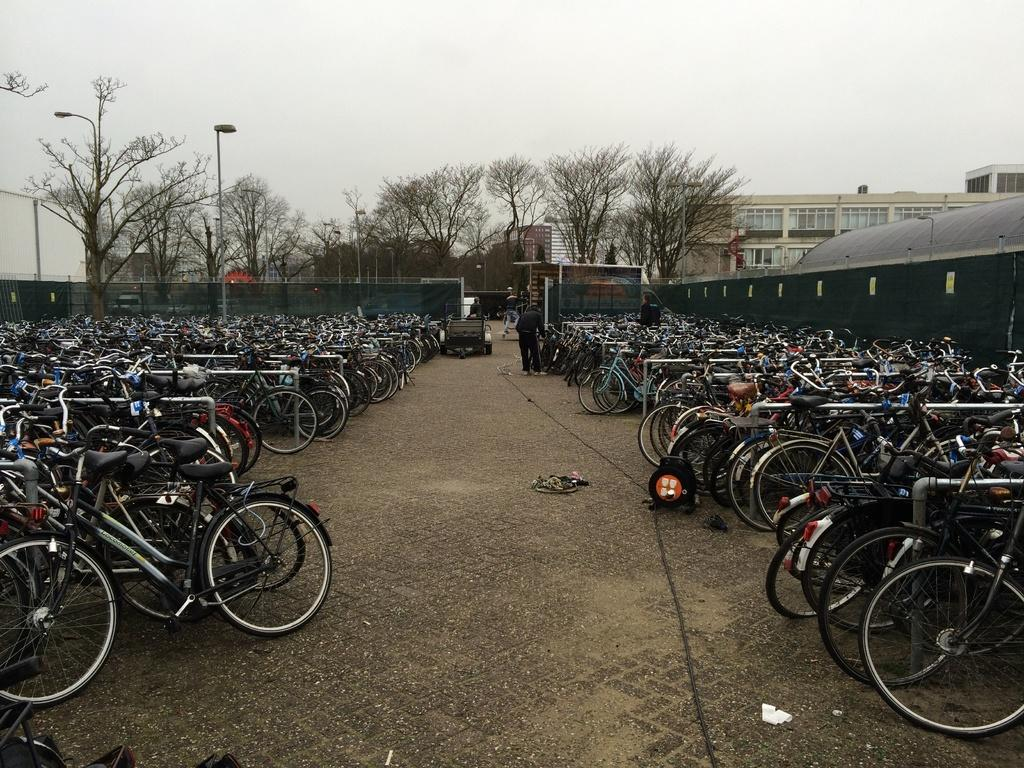What is the main subject of the image? The main subject of the image is a cycle parking lot. What can be seen in the background of the image? In the background of the image, there are buildings, trees, and poles. What is the color of the sky in the image? The sky in the image appears to be white in color. Can you see a spoon being used to dig a hole in the image? No, there is no spoon or any digging activity visible in the image. What type of rake is being used to clear the leaves in the image? There is no rake or any leaf-clearing activity visible in the image. 